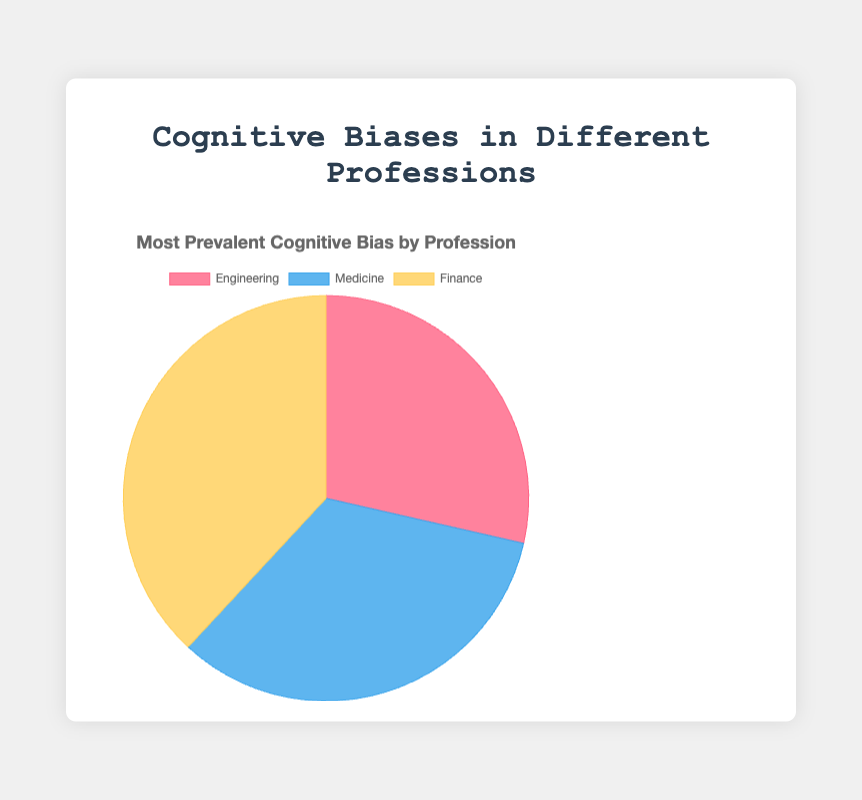What's the most prevalent cognitive bias in the field of Finance? According to the pie chart, each sector's most prevalent bias is highlighted. For Finance, the most prevalent bias is Overconfidence Bias.
Answer: Overconfidence Bias Which cognitive bias do Engineering and Medicine have in common as the most prevalent? By comparing the data labels in the pie chart, both Engineering and Medicine share Confirmation Bias as the most prevalent cognitive bias.
Answer: Confirmation Bias Which profession has the highest percentage of its most prevalent cognitive bias, and what is that percentage? Looking at the percentage values in the pie sections, Finance has the highest percentage for its most prevalent bias, which is Overconfidence Bias at 40%.
Answer: Finance, 40% What is the sum of the percentages for the most prevalent cognitive biases in all three professions? Summing up the percentages from the visual information: 30% (Engineering) + 35% (Medicine) + 40% (Finance) = 105%.
Answer: 105% Compare the prevalence of Confirmation Bias in Engineering and Medicine. Which profession exhibits a higher percentage, and by how much? Confirmation Bias in Engineering is 30%, while in Medicine, it's 35%. The difference is 35% - 30% = 5%. Medicine has a 5% higher prevalence.
Answer: Medicine, 5% Is the percentage of the most prevalent cognitive bias in Engineering greater than the percentage of the most prevalent bias in Medicine? Checking the numbers, Engineering has 30% for its most prevalent bias, while Medicine has 35%. Since 30% < 35%, the answer is no.
Answer: No What is the average percentage of the most prevalent cognitive biases across all professions? Summing the percentages and dividing by the number of professions gives (30 + 35 + 40) / 3 = 35%.
Answer: 35% What color represents Engineering's most prevalent cognitive bias in the chart? The chart uses color to represent different professions; Engineering's section is colored red.
Answer: Red 